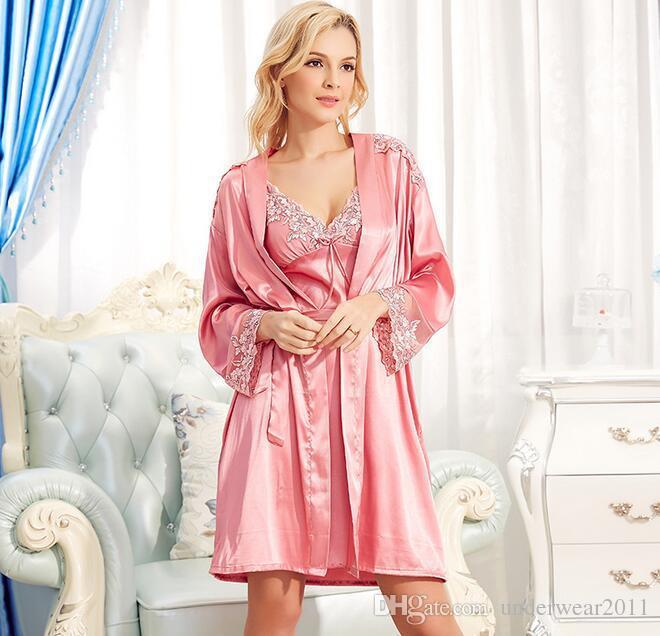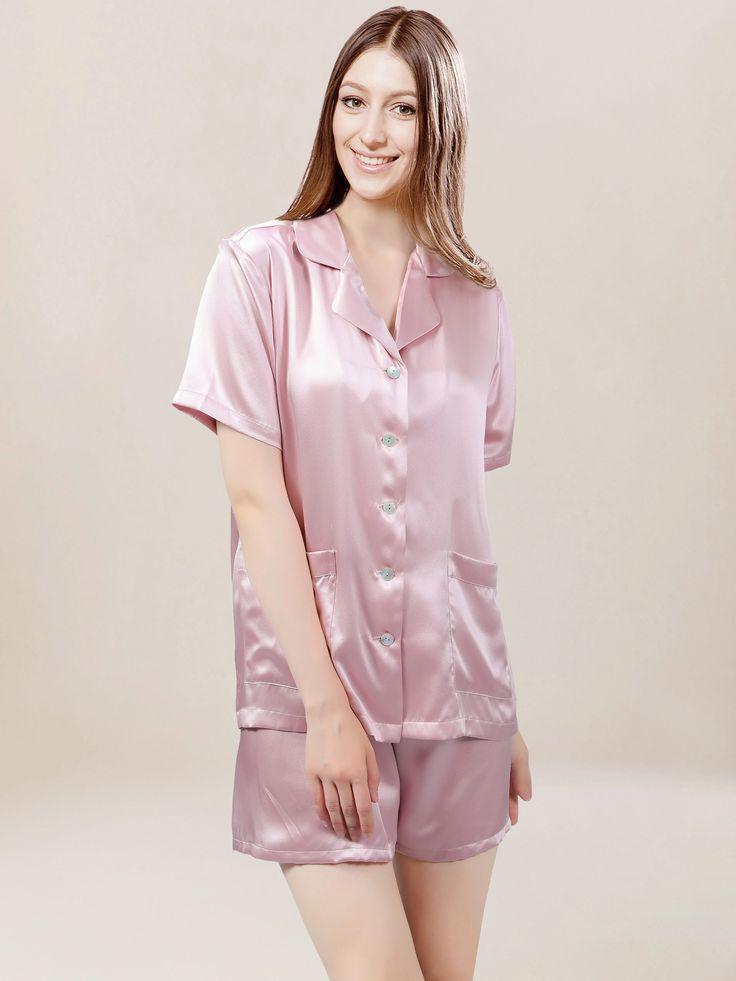The first image is the image on the left, the second image is the image on the right. Assess this claim about the two images: "The girl on the left is wearing a pink set of sleepwear.". Correct or not? Answer yes or no. Yes. The first image is the image on the left, the second image is the image on the right. Given the left and right images, does the statement "There is a woman facing right in the left image." hold true? Answer yes or no. Yes. 